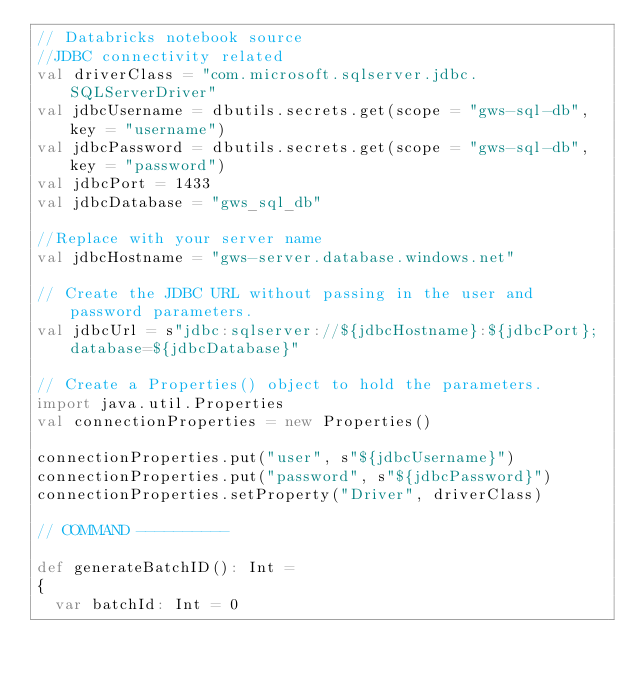<code> <loc_0><loc_0><loc_500><loc_500><_Scala_>// Databricks notebook source
//JDBC connectivity related
val driverClass = "com.microsoft.sqlserver.jdbc.SQLServerDriver"
val jdbcUsername = dbutils.secrets.get(scope = "gws-sql-db", key = "username")
val jdbcPassword = dbutils.secrets.get(scope = "gws-sql-db", key = "password")
val jdbcPort = 1433
val jdbcDatabase = "gws_sql_db"

//Replace with your server name
val jdbcHostname = "gws-server.database.windows.net"

// Create the JDBC URL without passing in the user and password parameters.
val jdbcUrl = s"jdbc:sqlserver://${jdbcHostname}:${jdbcPort};database=${jdbcDatabase}"

// Create a Properties() object to hold the parameters.
import java.util.Properties
val connectionProperties = new Properties()

connectionProperties.put("user", s"${jdbcUsername}")
connectionProperties.put("password", s"${jdbcPassword}")
connectionProperties.setProperty("Driver", driverClass)

// COMMAND ----------

def generateBatchID(): Int = 
{
  var batchId: Int = 0</code> 